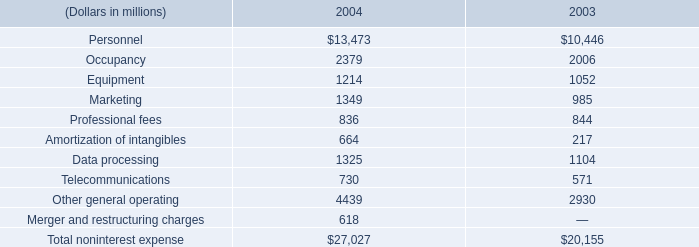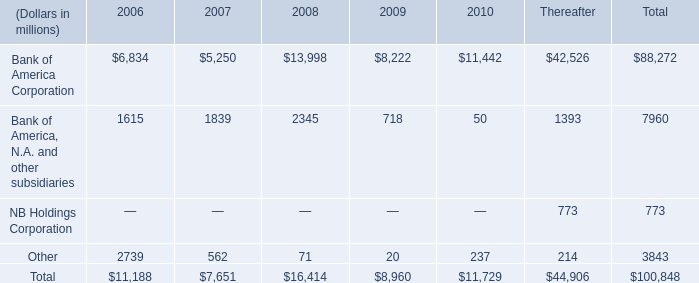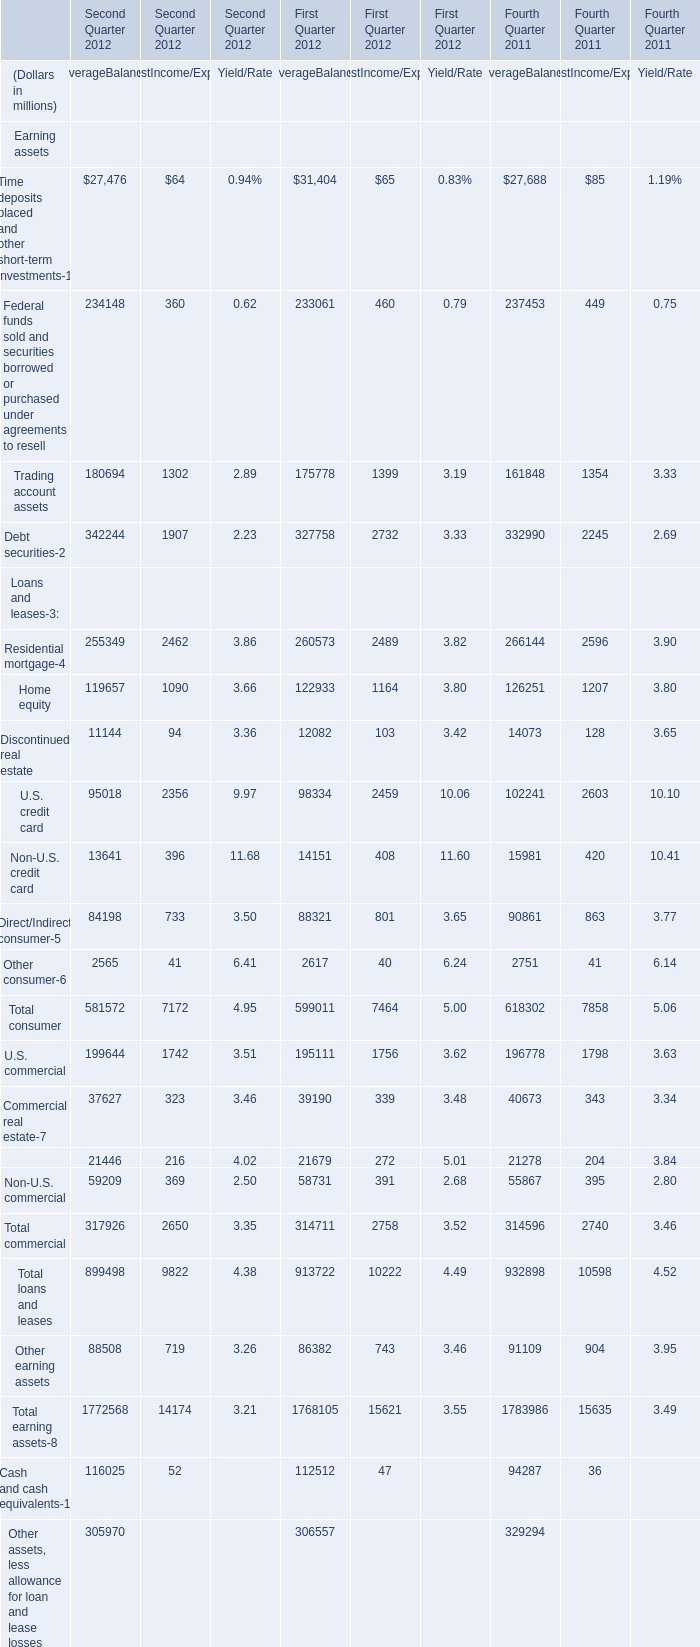What's the sum of U.S. credit card in the range of 2000 and 10000 in Second Quarter 2012 ? (in million) 
Computations: (95018 + 2356)
Answer: 97374.0. What's the average of Debt securities of Fourth Quarter 2011 InterestIncome/Expense, and Data processing of 2004 ? 
Computations: ((2245.0 + 1325.0) / 2)
Answer: 1785.0. What is the total amount of Bank of America, N.A. and other subsidiaries of 2006, and Direct/Indirect consumer of Second Quarter 2012 AverageBalance ? 
Computations: (1615.0 + 84198.0)
Answer: 85813.0. 